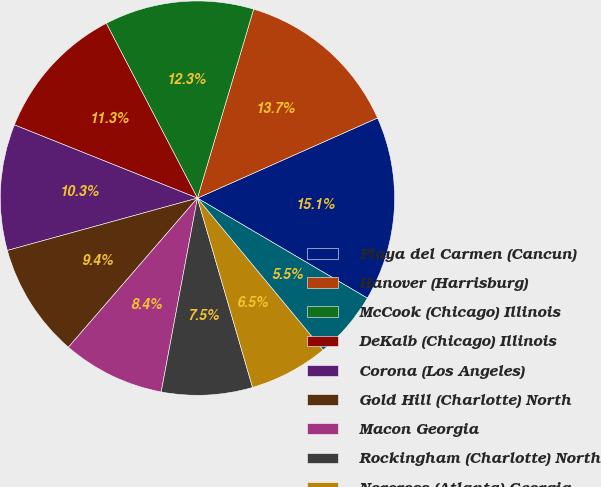Convert chart to OTSL. <chart><loc_0><loc_0><loc_500><loc_500><pie_chart><fcel>Playa del Carmen (Cancun)<fcel>Hanover (Harrisburg)<fcel>McCook (Chicago) Illinois<fcel>DeKalb (Chicago) Illinois<fcel>Corona (Los Angeles)<fcel>Gold Hill (Charlotte) North<fcel>Macon Georgia<fcel>Rockingham (Charlotte) North<fcel>Norcross (Atlanta) Georgia<fcel>1604 Stone (San Antonio) Texas<nl><fcel>15.13%<fcel>13.73%<fcel>12.25%<fcel>11.29%<fcel>10.33%<fcel>9.37%<fcel>8.41%<fcel>7.45%<fcel>6.49%<fcel>5.53%<nl></chart> 